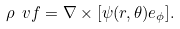<formula> <loc_0><loc_0><loc_500><loc_500>\rho \ v f = \nabla \times [ \psi ( r , \theta ) { e } _ { \phi } ] .</formula> 